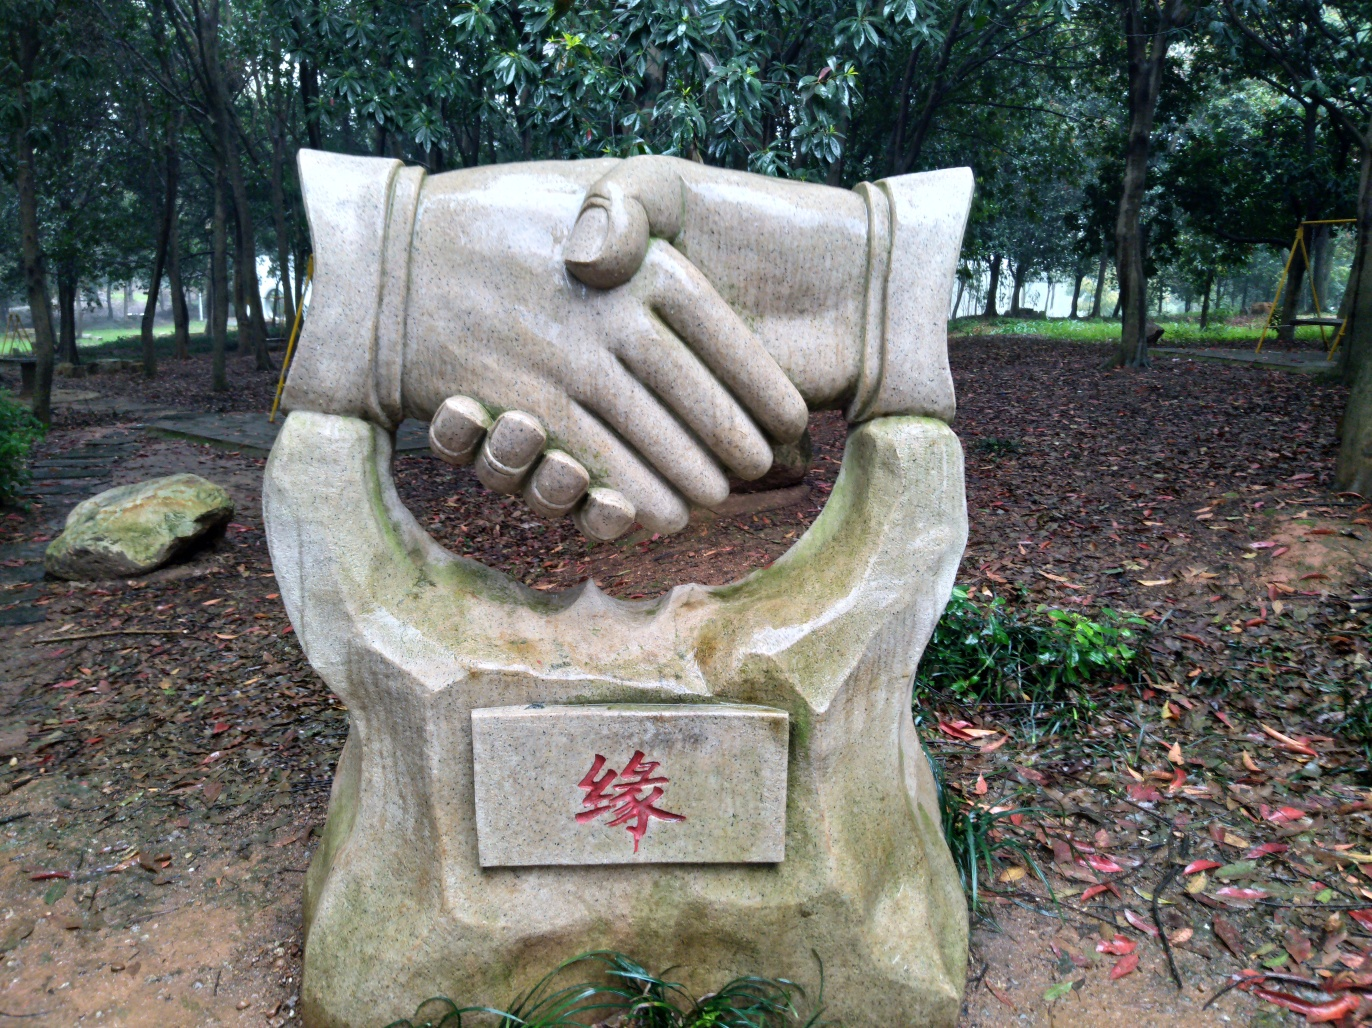Are the texture features of the sculpture clear? The texture features of the sculpture are indeed discernible, as you can see the intricate details, such as the lines on the palms, the folds around the knuckles, and the curves around the wrists. The overall craftsmanship offers a realistic portrayal, giving the sculpture a dynamic and tactile quality, even captured in this image. 